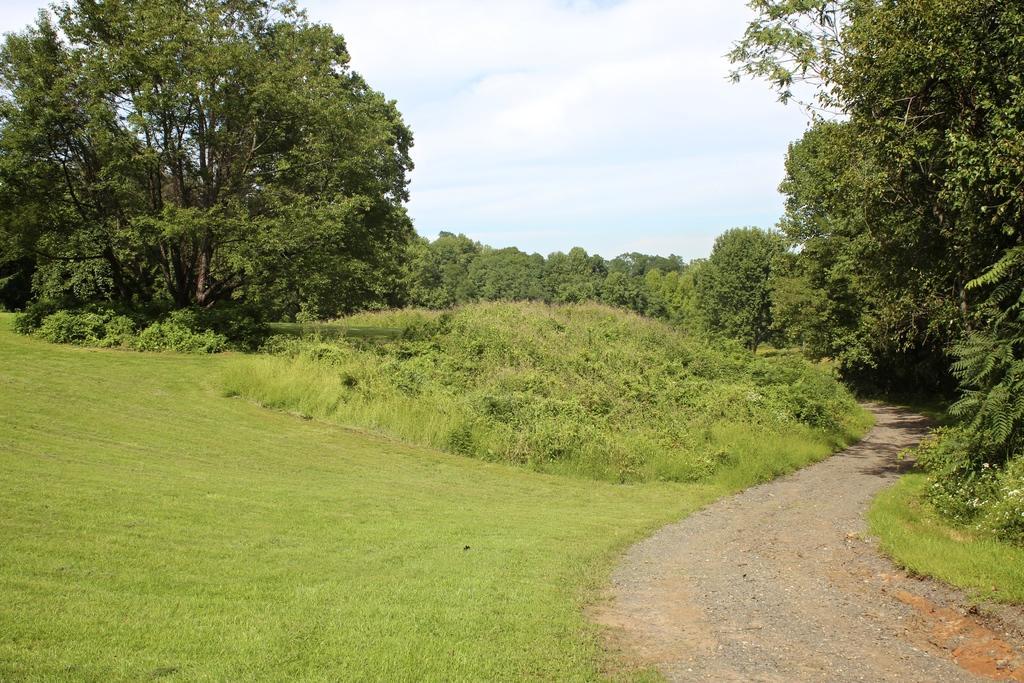Describe this image in one or two sentences. On the right side of the image there is a road. At the bottom of the image there is grass on the surface. In the background of the image there are trees and sky. 